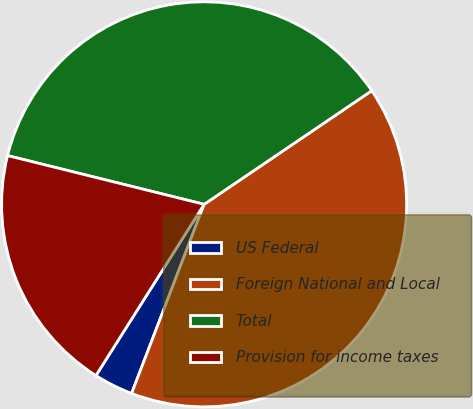<chart> <loc_0><loc_0><loc_500><loc_500><pie_chart><fcel>US Federal<fcel>Foreign National and Local<fcel>Total<fcel>Provision for income taxes<nl><fcel>3.14%<fcel>40.31%<fcel>36.65%<fcel>19.9%<nl></chart> 